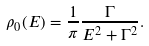Convert formula to latex. <formula><loc_0><loc_0><loc_500><loc_500>\rho _ { 0 } ( E ) = { \frac { 1 } { \pi } } { \frac { \Gamma } { { E ^ { 2 } + \Gamma ^ { 2 } } } } .</formula> 